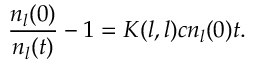Convert formula to latex. <formula><loc_0><loc_0><loc_500><loc_500>\frac { n _ { l } ( 0 ) } { n _ { l } ( t ) } - 1 = K ( l , l ) c n _ { l } ( 0 ) t .</formula> 